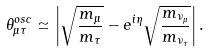<formula> <loc_0><loc_0><loc_500><loc_500>\theta _ { \mu \tau } ^ { o s c } \simeq \left | \sqrt { { \frac { m _ { \mu } } { m _ { \tau } } } } - e ^ { i \eta } \sqrt { { \frac { m _ { \nu _ { \mu } } } { m _ { \nu _ { \tau } } } } } \right | .</formula> 